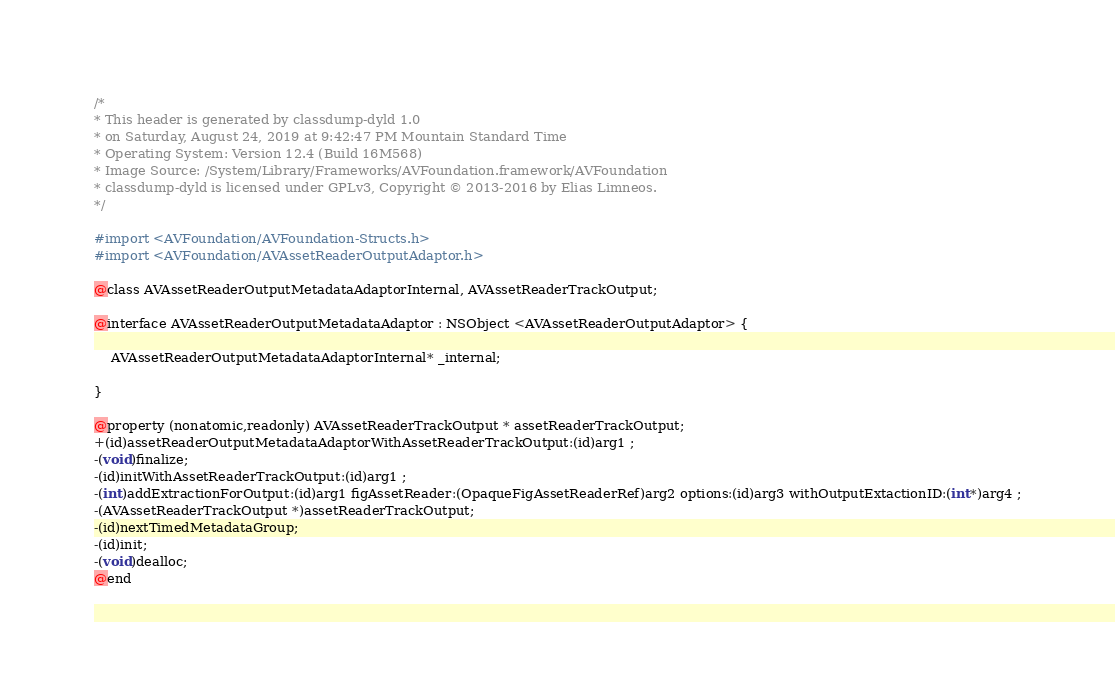<code> <loc_0><loc_0><loc_500><loc_500><_C_>/*
* This header is generated by classdump-dyld 1.0
* on Saturday, August 24, 2019 at 9:42:47 PM Mountain Standard Time
* Operating System: Version 12.4 (Build 16M568)
* Image Source: /System/Library/Frameworks/AVFoundation.framework/AVFoundation
* classdump-dyld is licensed under GPLv3, Copyright © 2013-2016 by Elias Limneos.
*/

#import <AVFoundation/AVFoundation-Structs.h>
#import <AVFoundation/AVAssetReaderOutputAdaptor.h>

@class AVAssetReaderOutputMetadataAdaptorInternal, AVAssetReaderTrackOutput;

@interface AVAssetReaderOutputMetadataAdaptor : NSObject <AVAssetReaderOutputAdaptor> {

	AVAssetReaderOutputMetadataAdaptorInternal* _internal;

}

@property (nonatomic,readonly) AVAssetReaderTrackOutput * assetReaderTrackOutput; 
+(id)assetReaderOutputMetadataAdaptorWithAssetReaderTrackOutput:(id)arg1 ;
-(void)finalize;
-(id)initWithAssetReaderTrackOutput:(id)arg1 ;
-(int)addExtractionForOutput:(id)arg1 figAssetReader:(OpaqueFigAssetReaderRef)arg2 options:(id)arg3 withOutputExtactionID:(int*)arg4 ;
-(AVAssetReaderTrackOutput *)assetReaderTrackOutput;
-(id)nextTimedMetadataGroup;
-(id)init;
-(void)dealloc;
@end

</code> 